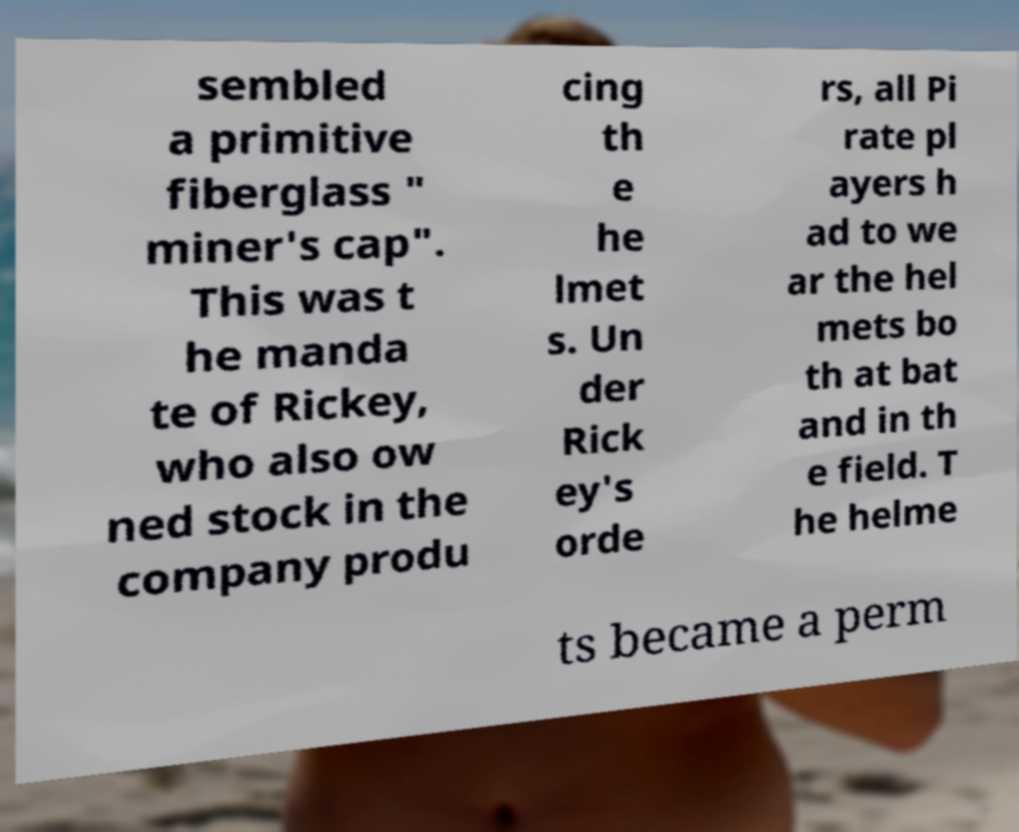Could you extract and type out the text from this image? sembled a primitive fiberglass " miner's cap". This was t he manda te of Rickey, who also ow ned stock in the company produ cing th e he lmet s. Un der Rick ey's orde rs, all Pi rate pl ayers h ad to we ar the hel mets bo th at bat and in th e field. T he helme ts became a perm 